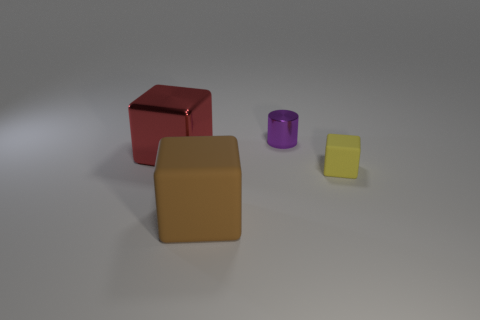Is the purple shiny cylinder the same size as the metallic block?
Ensure brevity in your answer.  No. How many things are either shiny things in front of the small metallic cylinder or things on the right side of the red thing?
Offer a very short reply. 4. Are there more big objects behind the small yellow cube than yellow shiny blocks?
Your answer should be very brief. Yes. What number of other objects are there of the same shape as the tiny purple metal object?
Your response must be concise. 0. There is a cube that is both behind the large rubber cube and left of the yellow rubber block; what is it made of?
Give a very brief answer. Metal. What number of things are large cyan rubber cylinders or objects?
Make the answer very short. 4. Are there more small cubes than small yellow shiny cubes?
Your answer should be very brief. Yes. There is a matte object in front of the matte cube to the right of the tiny purple object; what size is it?
Your response must be concise. Large. There is a large matte thing that is the same shape as the small yellow rubber thing; what is its color?
Your response must be concise. Brown. What is the size of the red object?
Keep it short and to the point. Large. 